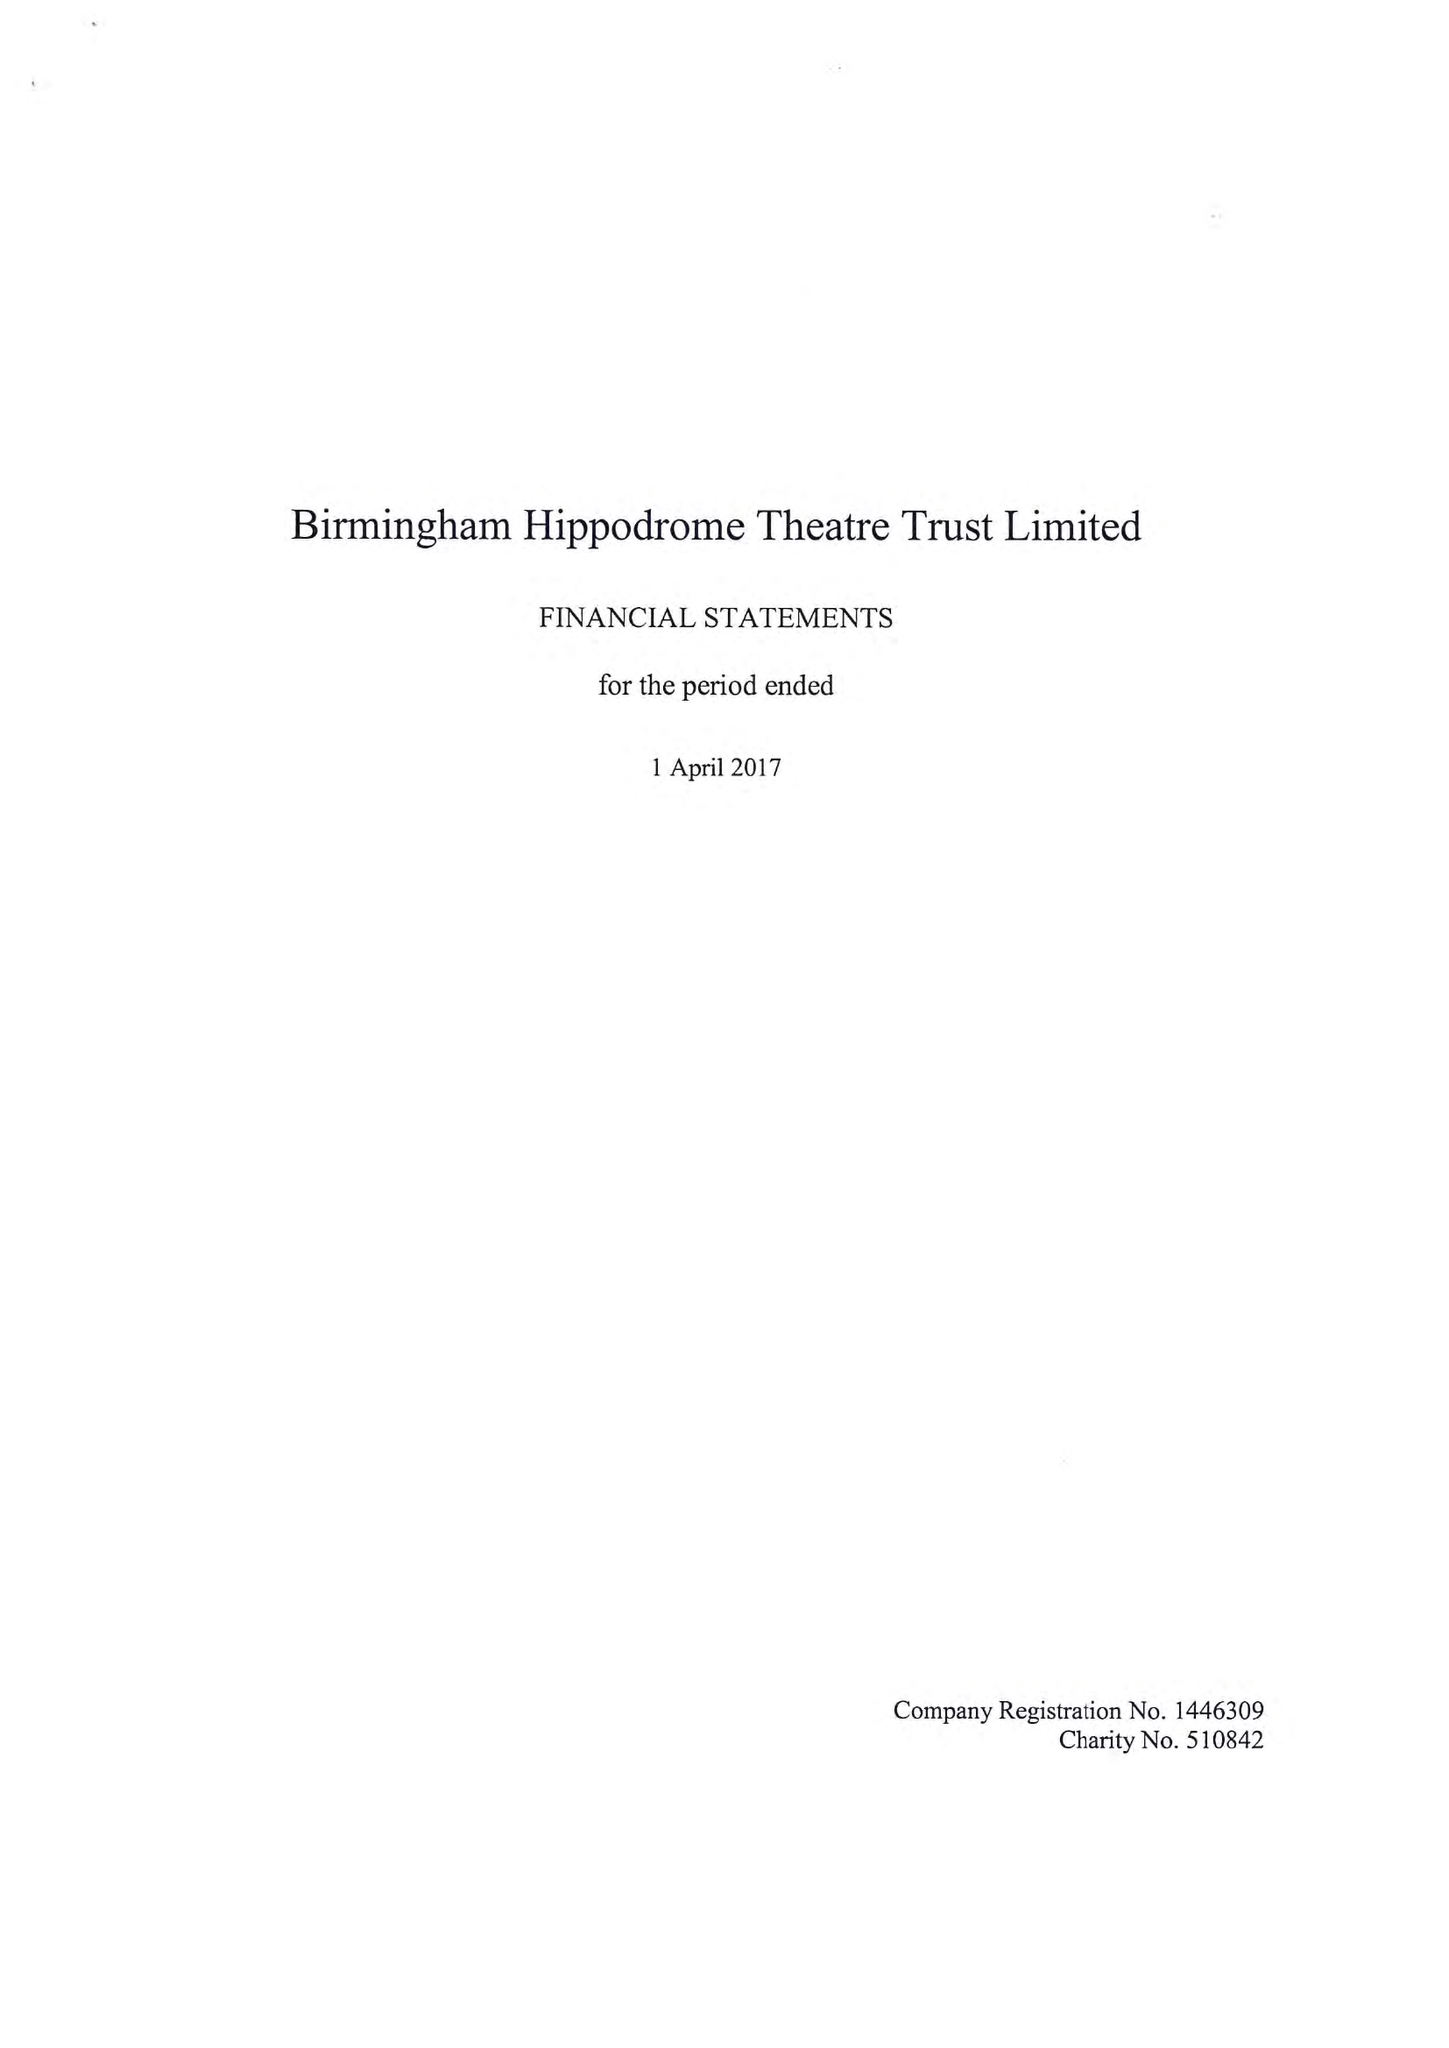What is the value for the spending_annually_in_british_pounds?
Answer the question using a single word or phrase. 27945000.00 